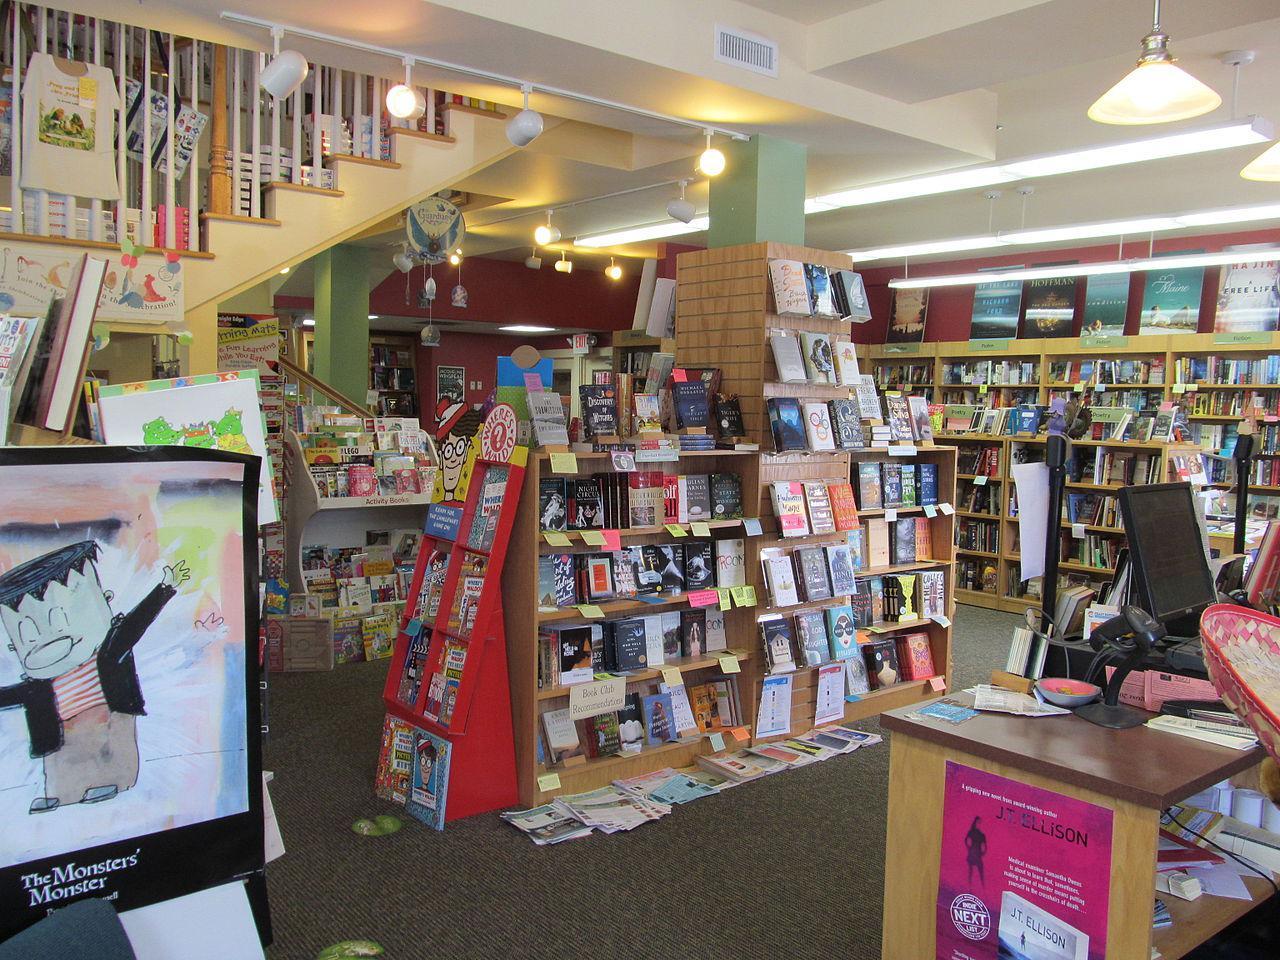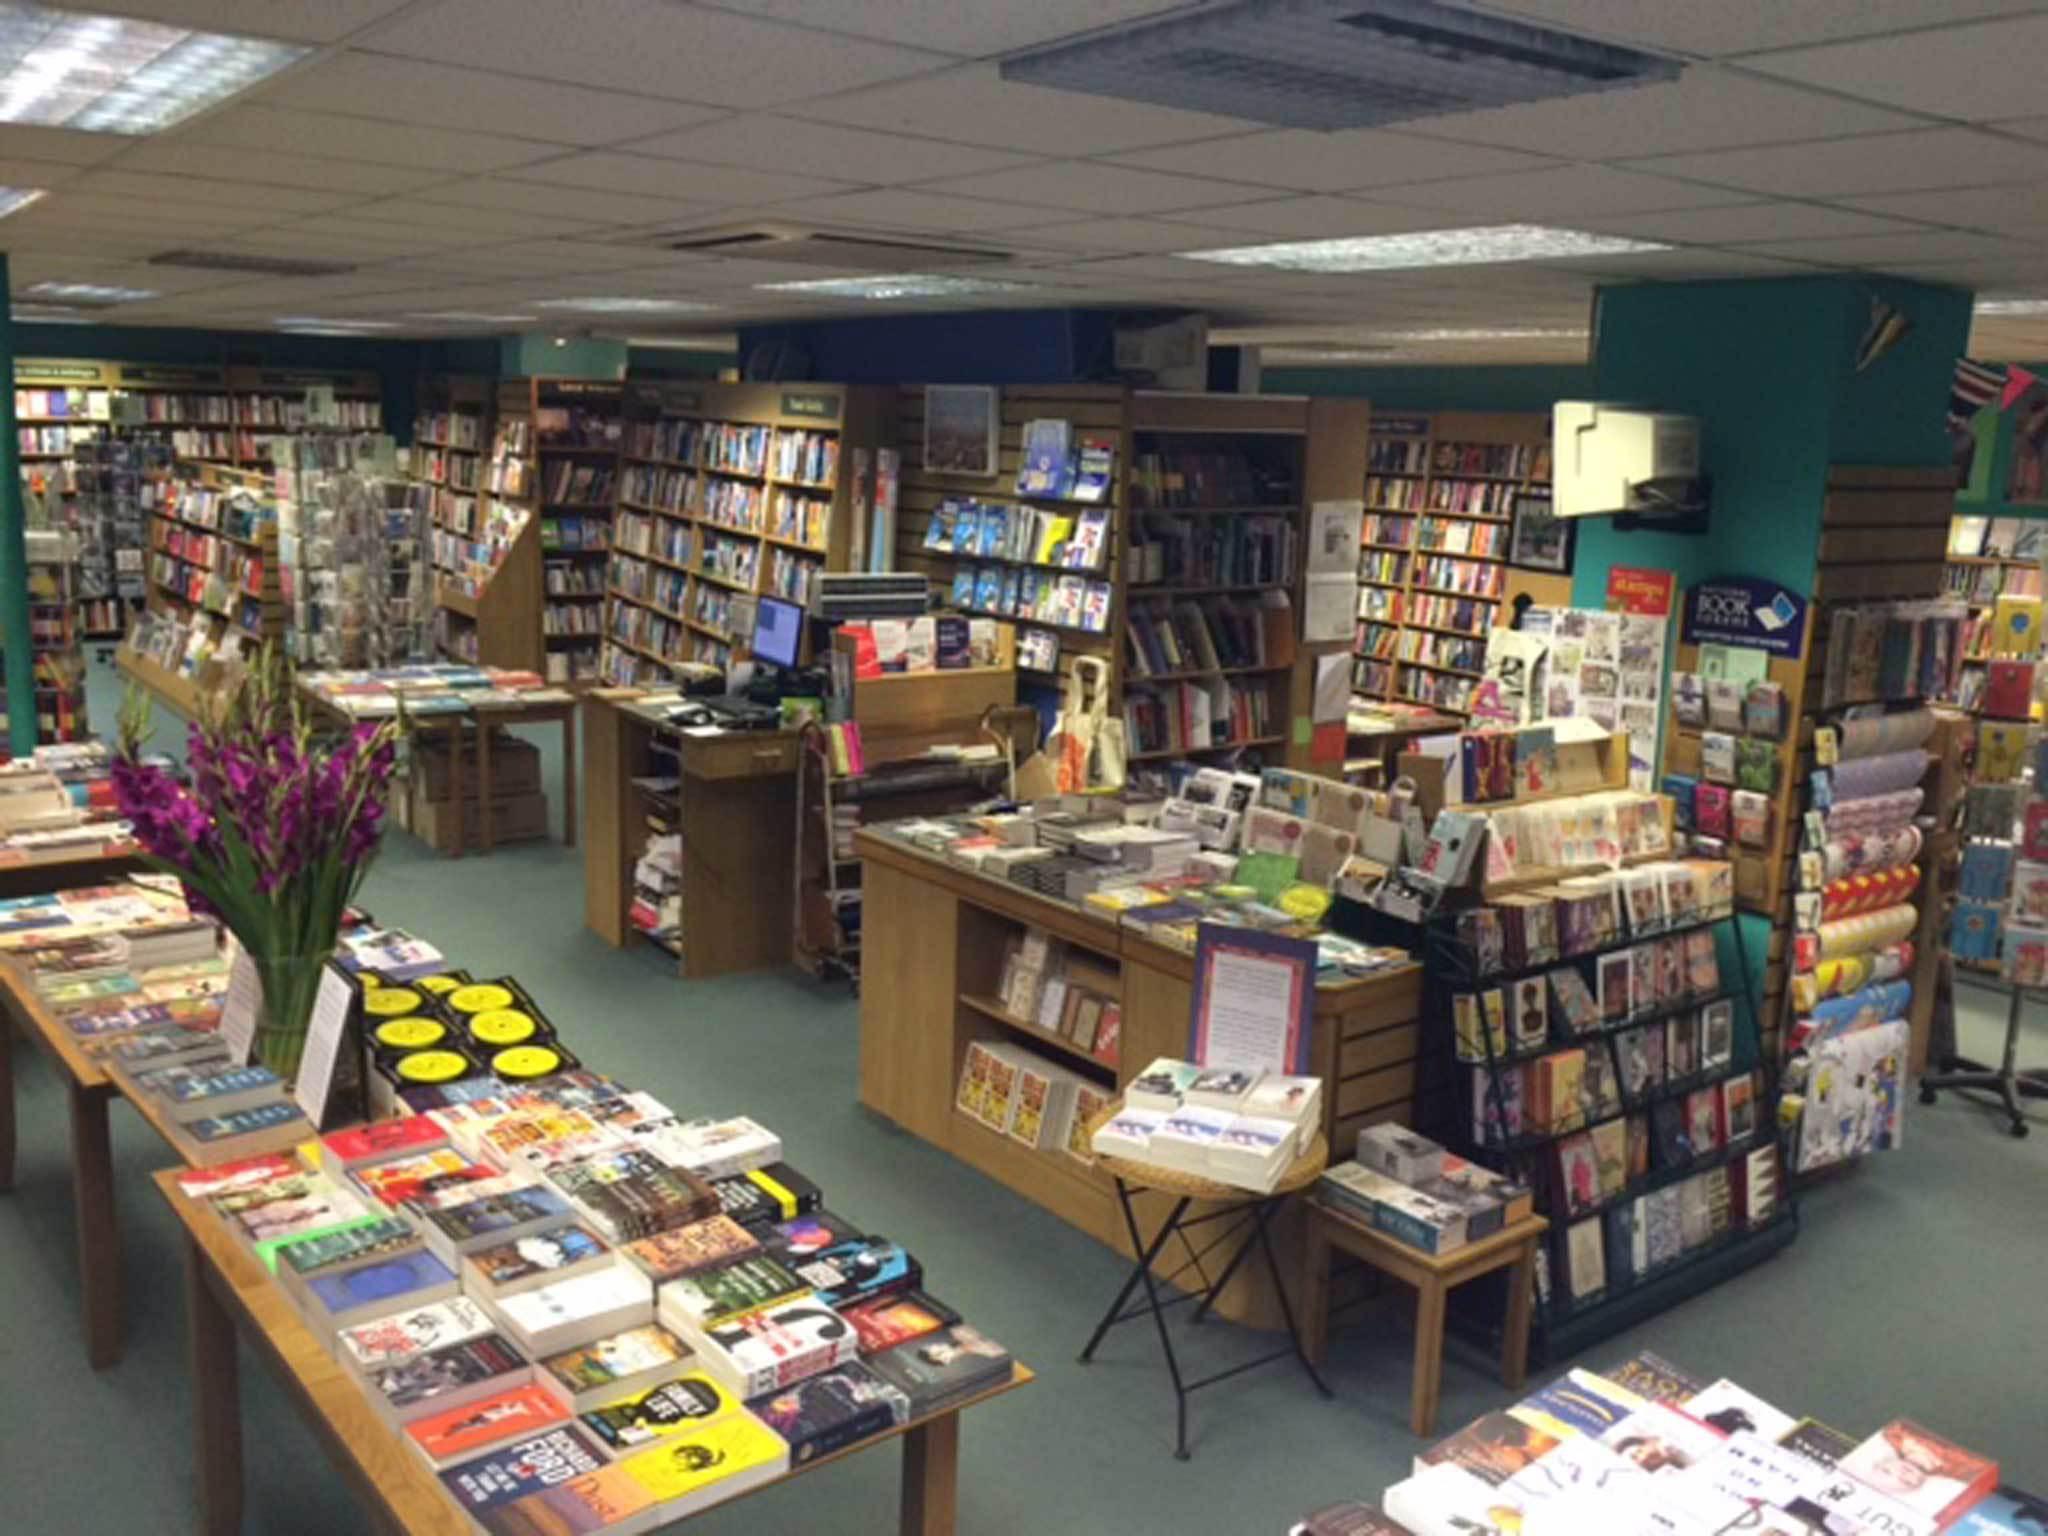The first image is the image on the left, the second image is the image on the right. Assess this claim about the two images: "No customers can be seen in either bookshop image.". Correct or not? Answer yes or no. Yes. 